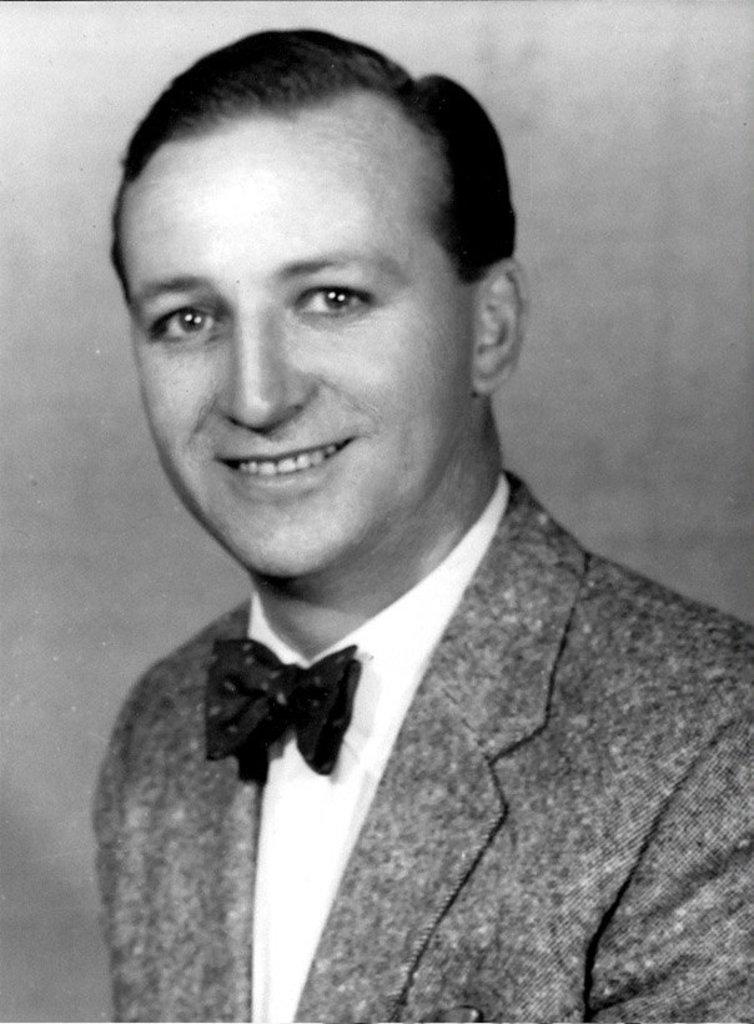How would you summarize this image in a sentence or two? In this image I can see the black and white picture in which I can see a person wearing blazer is smiling. 